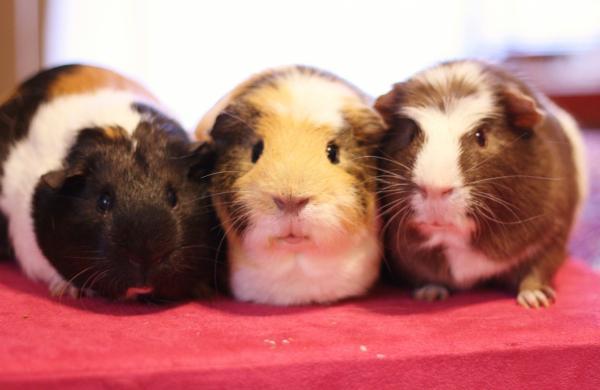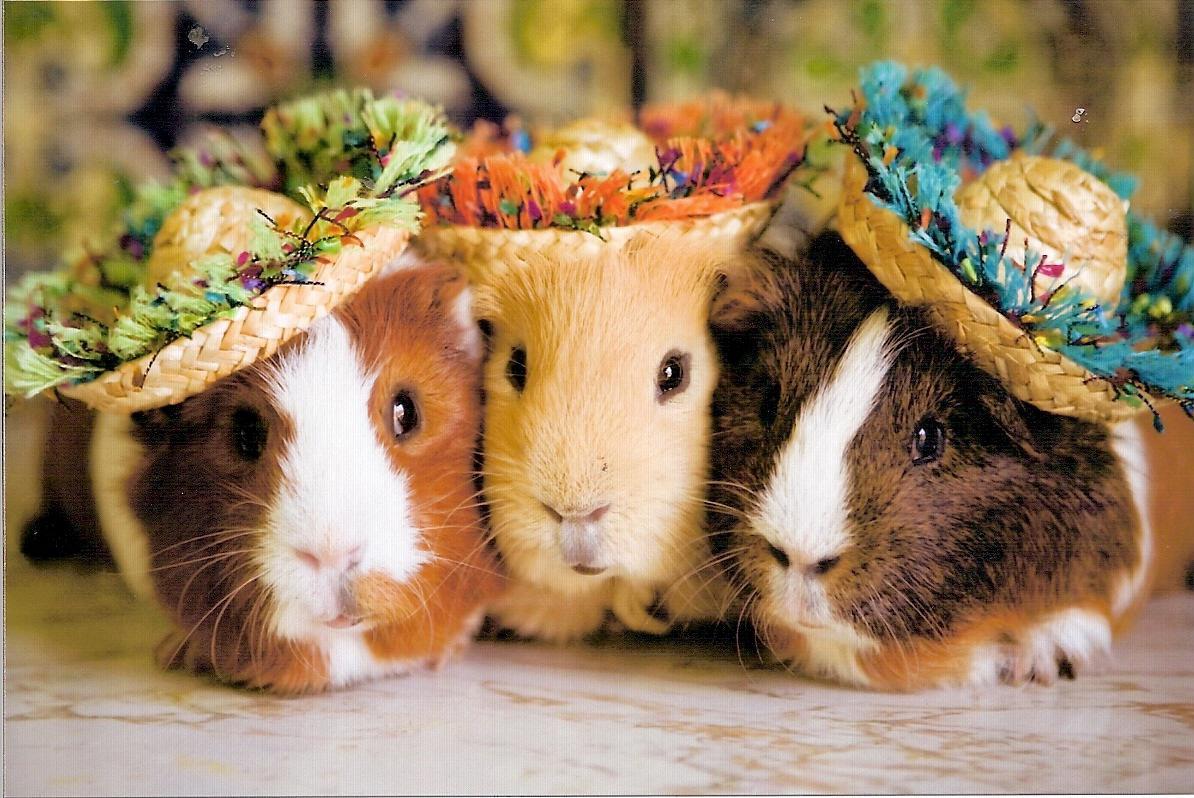The first image is the image on the left, the second image is the image on the right. Considering the images on both sides, is "The right image contains exactly five guinea pigs in a horizontal row." valid? Answer yes or no. No. The first image is the image on the left, the second image is the image on the right. For the images shown, is this caption "One image shows a horizontal row of five guinea pigs." true? Answer yes or no. No. 